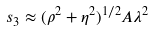Convert formula to latex. <formula><loc_0><loc_0><loc_500><loc_500>s _ { 3 } \approx ( \rho ^ { 2 } + \eta ^ { 2 } ) ^ { 1 / 2 } A \lambda ^ { 2 }</formula> 